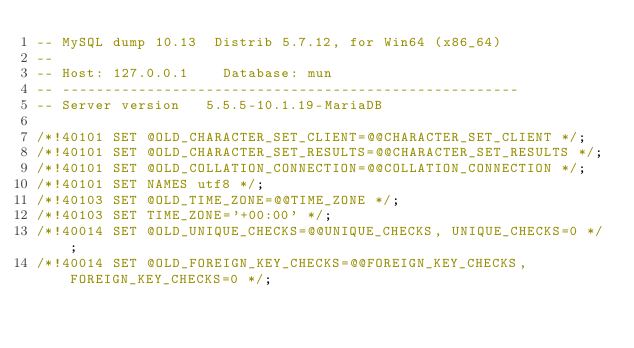Convert code to text. <code><loc_0><loc_0><loc_500><loc_500><_SQL_>-- MySQL dump 10.13  Distrib 5.7.12, for Win64 (x86_64)
--
-- Host: 127.0.0.1    Database: mun
-- ------------------------------------------------------
-- Server version	5.5.5-10.1.19-MariaDB

/*!40101 SET @OLD_CHARACTER_SET_CLIENT=@@CHARACTER_SET_CLIENT */;
/*!40101 SET @OLD_CHARACTER_SET_RESULTS=@@CHARACTER_SET_RESULTS */;
/*!40101 SET @OLD_COLLATION_CONNECTION=@@COLLATION_CONNECTION */;
/*!40101 SET NAMES utf8 */;
/*!40103 SET @OLD_TIME_ZONE=@@TIME_ZONE */;
/*!40103 SET TIME_ZONE='+00:00' */;
/*!40014 SET @OLD_UNIQUE_CHECKS=@@UNIQUE_CHECKS, UNIQUE_CHECKS=0 */;
/*!40014 SET @OLD_FOREIGN_KEY_CHECKS=@@FOREIGN_KEY_CHECKS, FOREIGN_KEY_CHECKS=0 */;</code> 